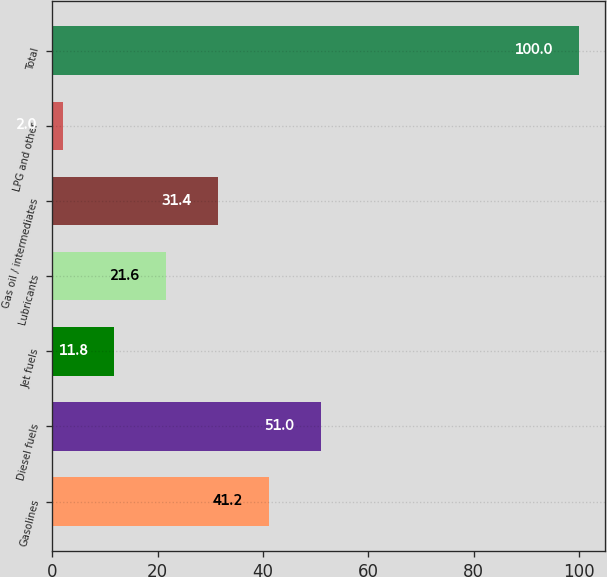Convert chart. <chart><loc_0><loc_0><loc_500><loc_500><bar_chart><fcel>Gasolines<fcel>Diesel fuels<fcel>Jet fuels<fcel>Lubricants<fcel>Gas oil / intermediates<fcel>LPG and other<fcel>Total<nl><fcel>41.2<fcel>51<fcel>11.8<fcel>21.6<fcel>31.4<fcel>2<fcel>100<nl></chart> 